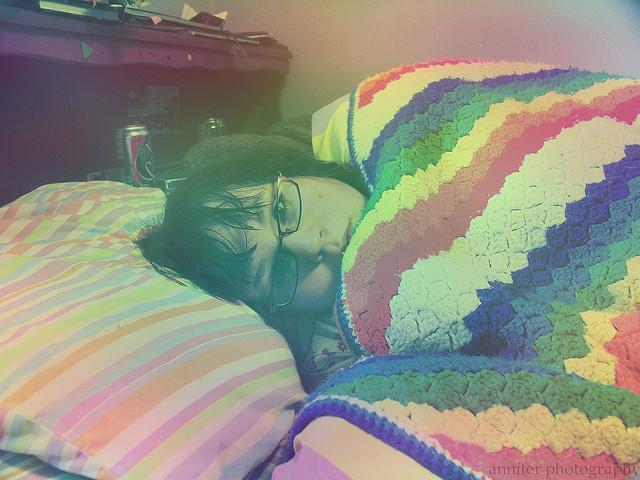How many beds are there?
Give a very brief answer. 1. 